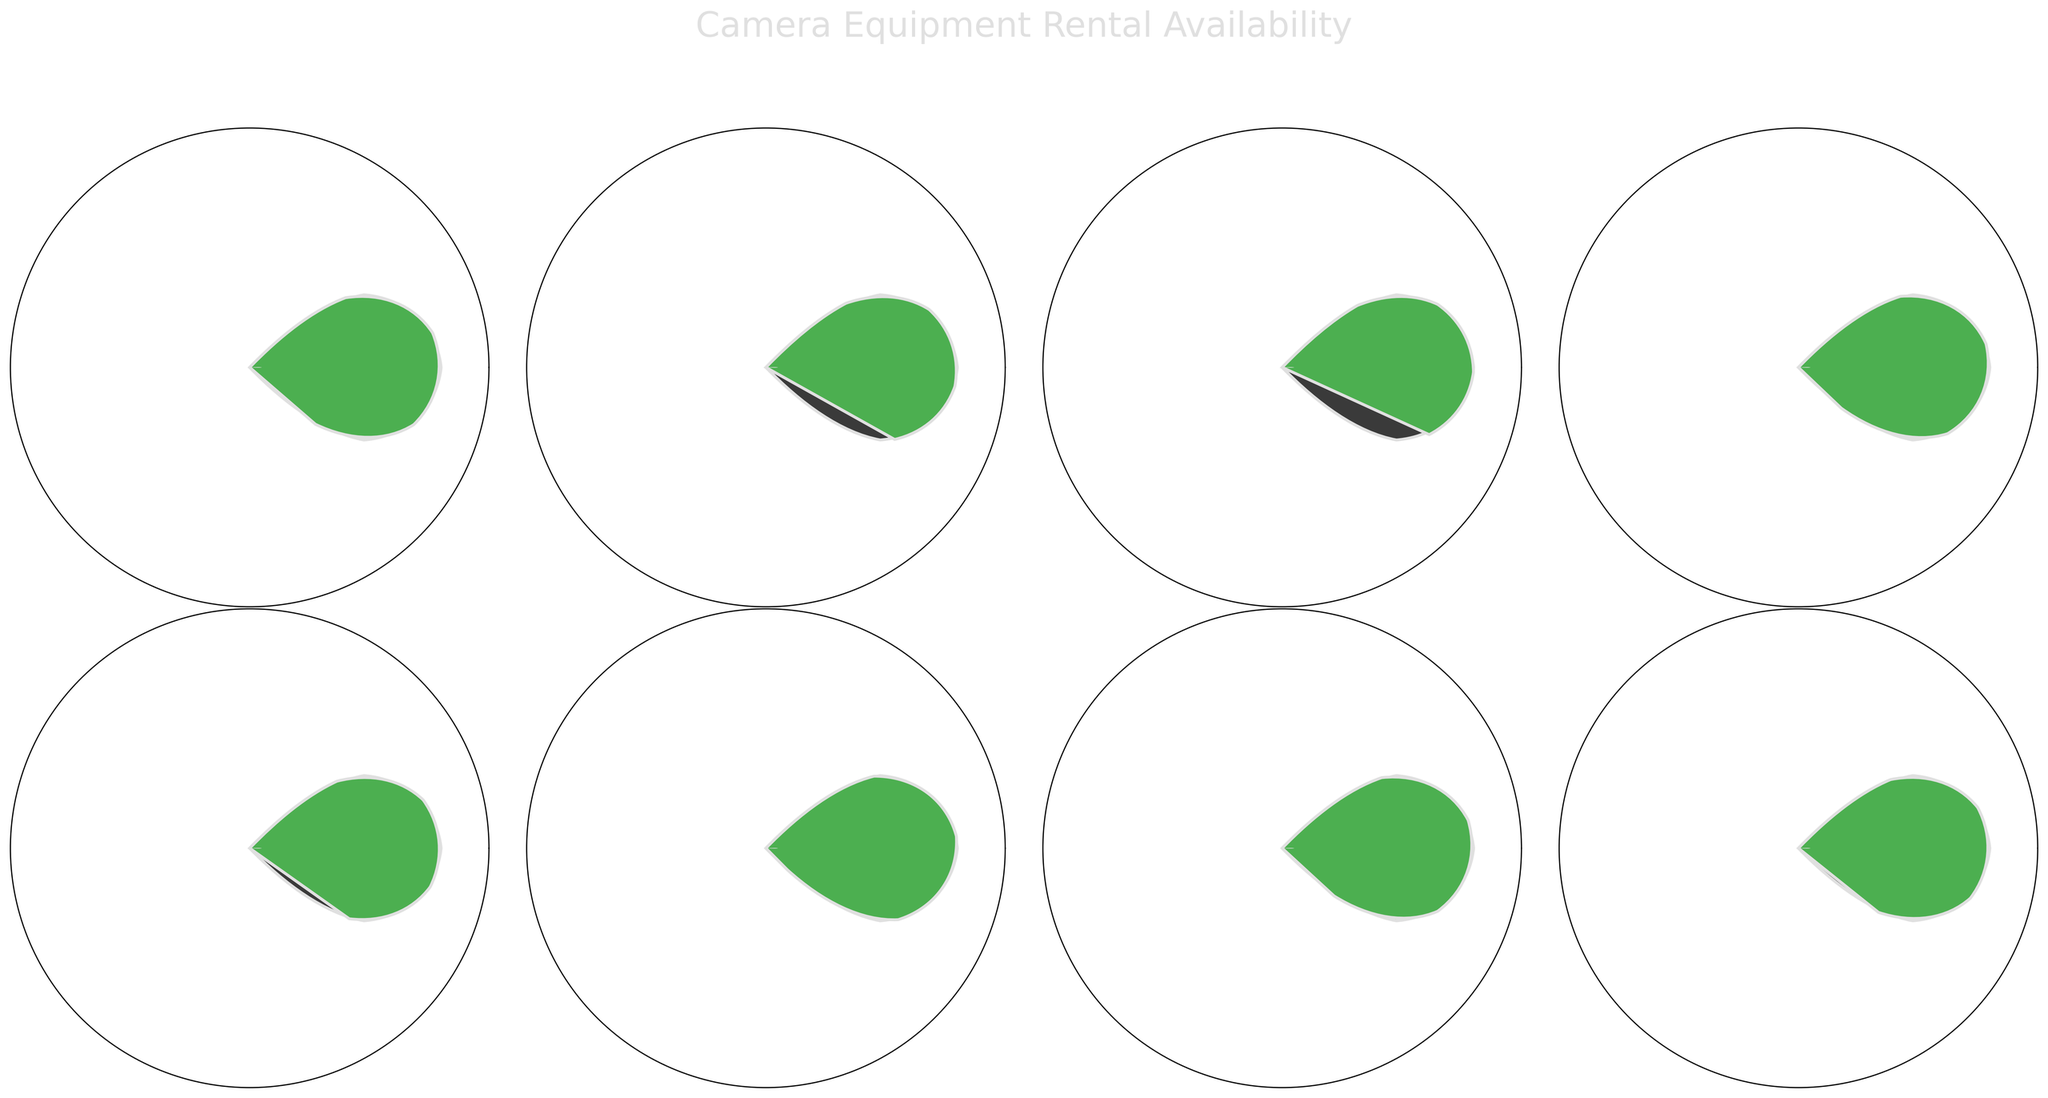What's the availability percentage of the Sony Venice? The figure shows different equipment names along with their corresponding availability percentages. Look at the gauge labeled "Sony Venice."
Answer: 68% Which piece of equipment has the highest availability percentage? Compare the percentages shown within each gauge. The one with the highest percentage is the DJI Ronin 2 Gimbal with a gauge showing 95%.
Answer: DJI Ronin 2 Gimbal What is the range of availability percentages displayed in the figure? Identify the minimum and maximum values from the percentages: the lowest is 68% for Sony Venice and the highest is 95% for DJI Ronin 2 Gimbal. The range is 95% - 68% = 27%.
Answer: 27% How many pieces of equipment have an availability percentage greater than 80%? Count the gauges with percentages higher than 80%. They are: Arri Alexa LF (85%), Cooke S4 Lens Set (90%), DJI Ronin 2 Gimbal (95%), ARRI SkyPanel S60-C (88%), Teradek Bolt 3000 XT (82%). There are 5 pieces of equipment.
Answer: 5 What's the average availability percentage of all equipment listed? Sum all the availability percentages and divide by the number of equipment. (85 + 72 + 68 + 90 + 78 + 95 + 88 + 82) / 8 = 82%.
Answer: 82% Is the availability percentage of Arri Alexa LF higher than the Cooke S4 Lens Set? Compare the percentages of Arri Alexa LF (85%) and Cooke S4 Lens Set (90%). 85% is less than 90%.
Answer: No What is the median availability percentage of the listed equipment? Arrange the percentages in ascending order: 68, 72, 78, 82, 85, 88, 90, 95. The median is the average of the 4th and 5th values: (82 + 85) / 2 = 83.5%.
Answer: 83.5% Which item has an availability percentage closest to 80%? Look at the percentages and find the one closest to 80%. Teradek Bolt 3000 XT has 82%, and Angenieux Optimo Zoom has 78%. Both are closest, but Teradek Bolt 3000 XT is slightly closer.
Answer: Teradek Bolt 3000 XT For which equipment is the availability percentage displayed under their names? Each gauge shows the equipment name under the percentage text. For example, "Arri Alexa LF" below "85%".
Answer: All equipment 